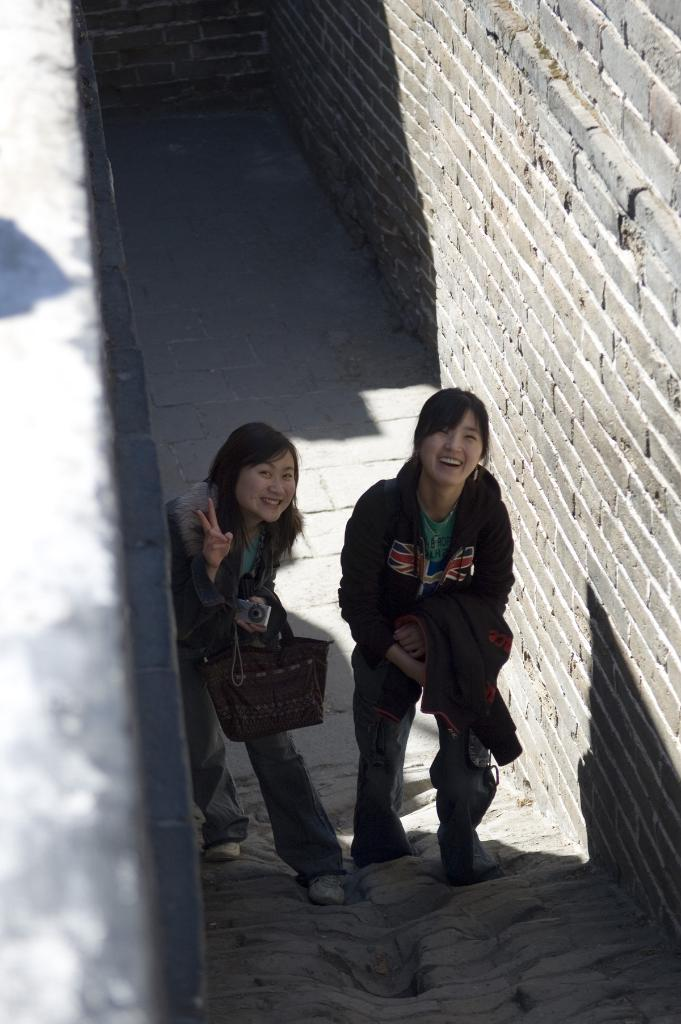How many people are in the image? There are two women in the image. What are the women doing in the image? The women are standing and smiling. What objects are the women holding? One of the women is holding a bag, and the other is holding a camera. What can be seen in the background of the image? There is a wall visible in the image. Can you tell me how the crook is helping the women in the image? There is no crook present in the image, and therefore no such interaction can be observed. 